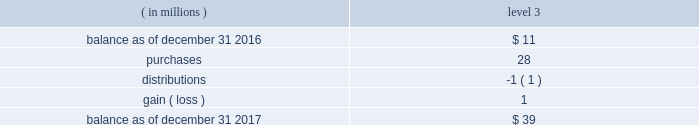For securities that are quoted in active markets , the trustee/ custodian determines fair value by applying securities 2019 prices obtained from its pricing vendors .
For commingled funds that are not actively traded , the trustee applies pricing information provided by investment management firms to the unit quanti- ties of such funds .
Investment management firms employ their own pricing vendors to value the securities underlying each commingled fund .
Underlying securities that are not actively traded derive their prices from investment managers , which in turn , employ vendors that use pricing models ( e.g. , discounted cash flow , comparables ) .
The domestic defined benefit plans have no investment in our stock , except through the s&p 500 commingled trust index fund .
The trustee obtains estimated prices from vendors for secu- rities that are not easily quotable and they are categorized accordingly as level 3 .
The table details further information on our plan assets where we have used significant unobservable inputs ( level 3 ) : .
Pension trusts 2019 asset allocations there are two pension trusts , one in the u.s .
And one in the u.k .
The u.s .
Pension trust had assets of $ 1739 a0 million and $ 1632 a0million as of december a031 , 2017 and 2016 respectively , and the target allocations in 2017 include 68% ( 68 % ) fixed income , 27% ( 27 % ) domestic equities and 5% ( 5 % ) international equities .
The u.k .
Pension trust had assets of $ 480 a0 million and $ 441 a0 million as of december a0 31 , 2017 and 2016 , respec- tively , and the target allocations in 2017 include 40% ( 40 % ) fixed income , 30% ( 30 % ) diversified growth funds , 20% ( 20 % ) equities and 10% ( 10 % ) real estate .
The pension assets are invested with the goal of producing a combination of capital growth , income and a liability hedge .
The mix of assets is established after consideration of the long- term performance and risk characteristics of asset classes .
Investments are selected based on their potential to enhance returns , preserve capital and reduce overall volatility .
Holdings are diversified within each asset class .
The portfolios employ a mix of index and actively managed equity strategies by market capitalization , style , geographic regions and economic sec- tors .
The fixed income strategies include u.s .
Long duration securities , opportunistic fixed income securities and u.k .
Debt instruments .
The short-term portfolio , whose primary goal is capital preservation for liquidity purposes , is composed of gov- ernment and government- agency securities , uninvested cash , receivables and payables .
The portfolios do not employ any financial leverage .
U.s .
Defined contribution plans assets of the defined contribution plans in the u.s .
Consist pri- marily of investment options which include actively managed equity , indexed equity , actively managed equity/bond funds , target date funds , s&p global inc .
Common stock , stable value and money market strategies .
There is also a self- directed mutual fund investment option .
The plans purchased 228248 shares and sold 297750 shares of s&p global inc .
Common stock in 2017 and purchased 216035 shares and sold 437283 shares of s&p global inc .
Common stock in 2016 .
The plans held approximately 1.5 a0million shares of s&p global inc .
Com- mon stock as of december a031 , 2017 and 1.6 a0million shares as of december a031 , 2016 , with market values of $ 255 a0million and $ 171 a0million , respectively .
The plans received dividends on s&p global inc .
Common stock of $ 3 a0million and $ 2 a0million during the years ended december a031 , 2017 and december a031 , 2016 respectively .
Stock-based compensation we issue stock-based incentive awards to our eligible employ- ees and directors under the 2002 employee stock incentive plan and a director deferred stock ownership plan .
2002 employee stock incentive plan ( the 201c2002 plan 201d ) 2014 the 2002 plan permits the granting of nonquali- fied stock options , stock appreciation rights , performance stock , restricted stock and other stock-based awards .
Director deferred stock ownership plan 2014 under this plan , common stock reserved may be credited to deferred stock accounts for eligible directors .
In general , the plan requires that 50% ( 50 % ) of eligible directors 2019 annual com- pensation plus dividend equivalents be credited to deferred stock accounts .
Each director may also elect to defer all or a portion of the remaining compensation and have an equiva- lent number of shares credited to the deferred stock account .
Recipients under this plan are not required to provide con- sideration to us other than rendering service .
Shares will be delivered as of the date a recipient ceases to be a member of the board of directors or within five years thereafter , if so elected .
The plan will remain in effect until terminated by the board of directors or until no shares of stock remain avail- able under the plan .
S&p global 2017 annual report 71 .
What was the ratio of the pension trust assets for 2017 to 2016 $ 1739 million and $ 1632? 
Rationale: for every dollar of pension trust assets in 2016 there was $ 1.1 in 2017
Computations: (1739 / 1632)
Answer: 1.06556. 